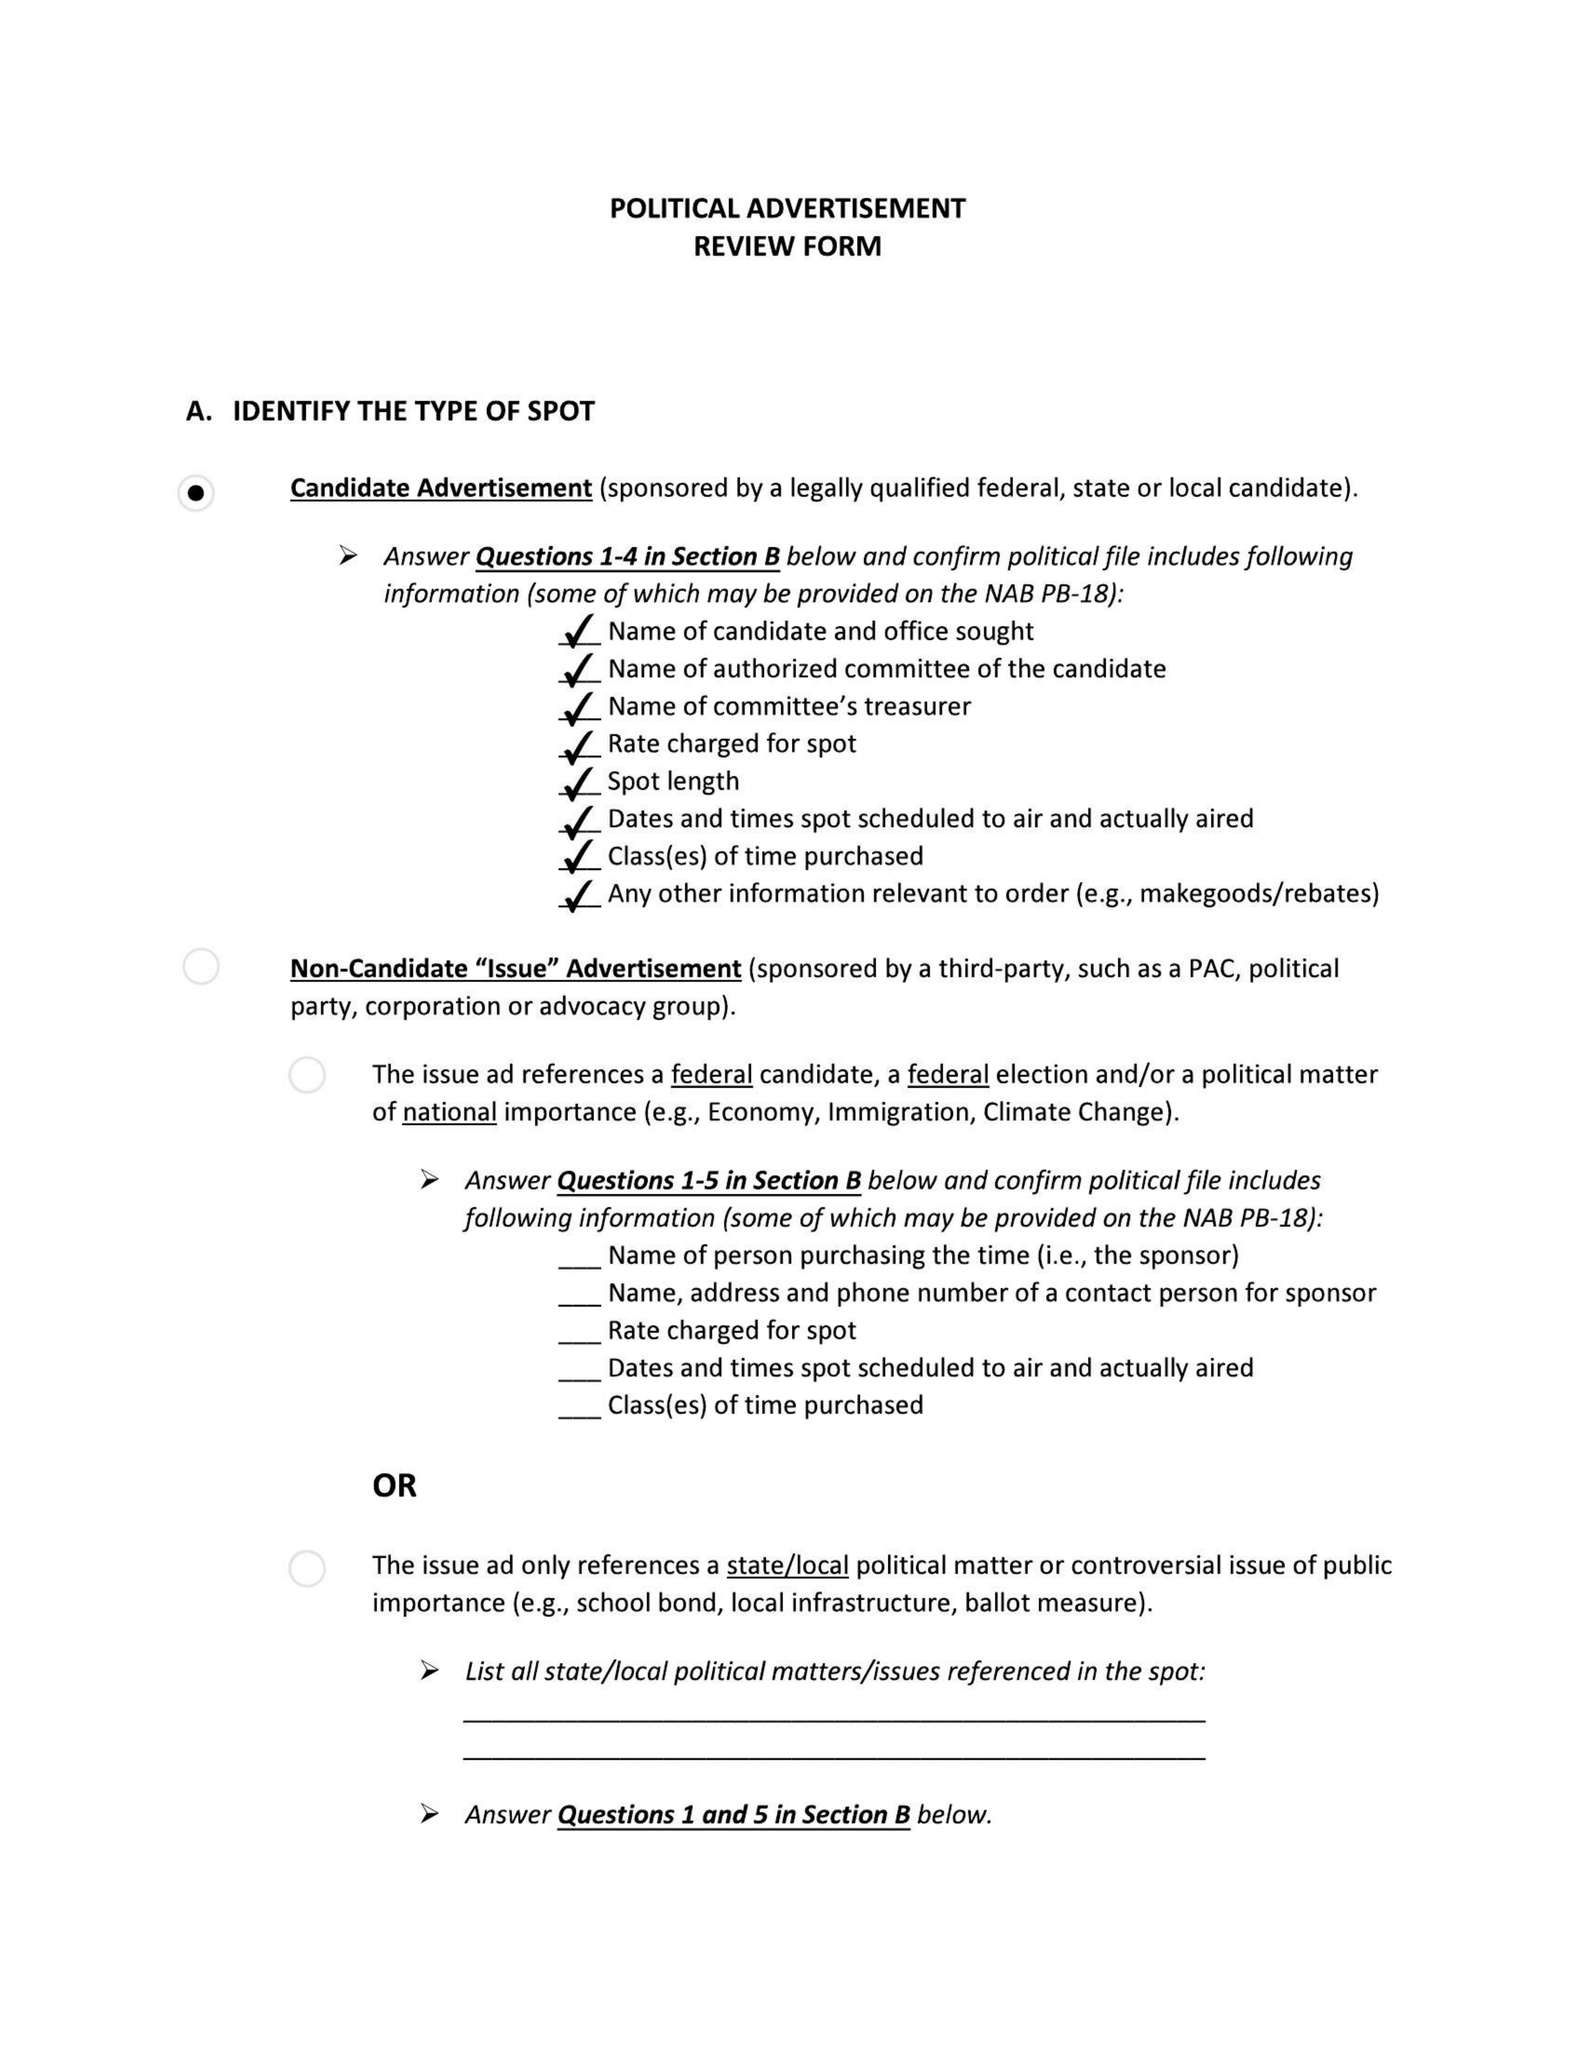What is the value for the advertiser?
Answer the question using a single word or phrase. MIKE BLOOMBERG 